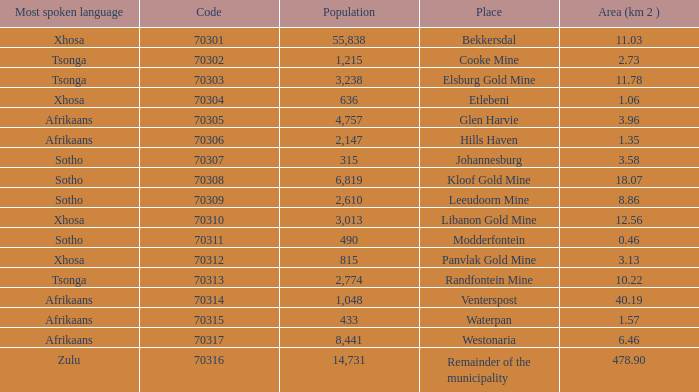What is the low code for glen harvie with a population greater than 2,774? 70305.0. 